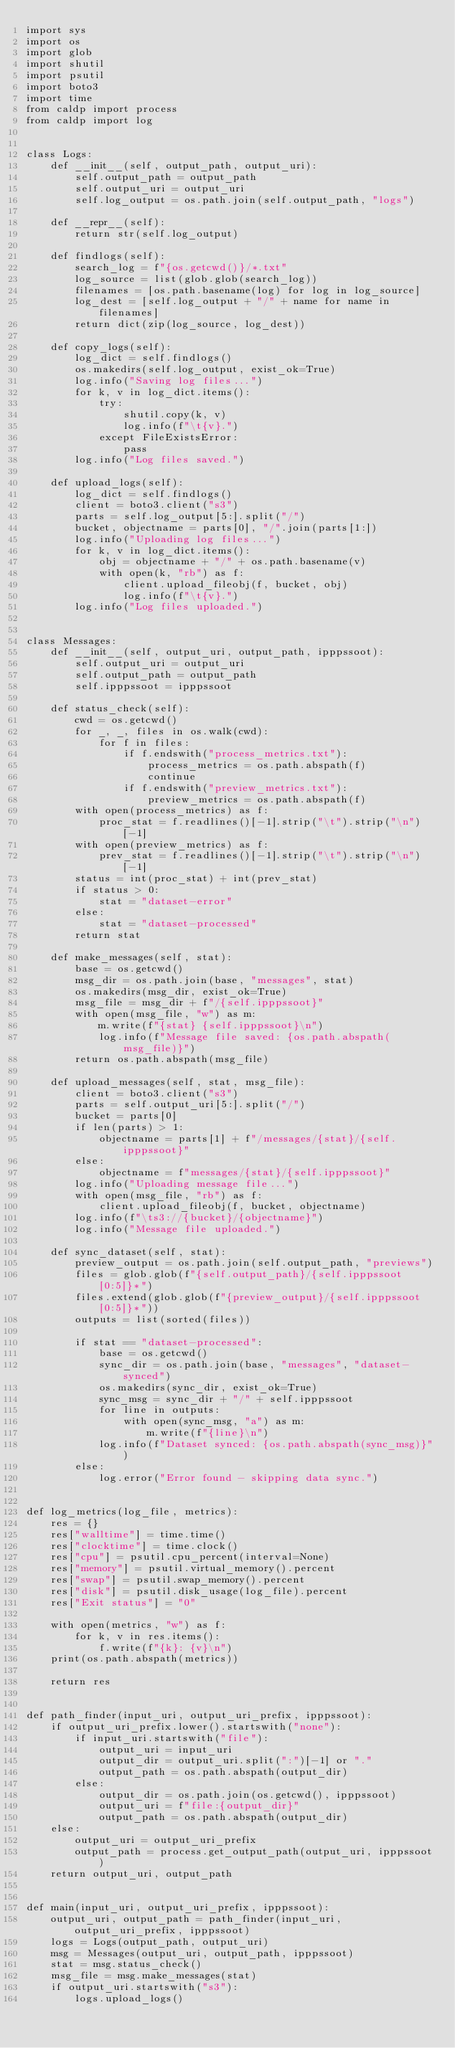<code> <loc_0><loc_0><loc_500><loc_500><_Python_>import sys
import os
import glob
import shutil
import psutil
import boto3
import time
from caldp import process
from caldp import log


class Logs:
    def __init__(self, output_path, output_uri):
        self.output_path = output_path
        self.output_uri = output_uri
        self.log_output = os.path.join(self.output_path, "logs")

    def __repr__(self):
        return str(self.log_output)

    def findlogs(self):
        search_log = f"{os.getcwd()}/*.txt"
        log_source = list(glob.glob(search_log))
        filenames = [os.path.basename(log) for log in log_source]
        log_dest = [self.log_output + "/" + name for name in filenames]
        return dict(zip(log_source, log_dest))

    def copy_logs(self):
        log_dict = self.findlogs()
        os.makedirs(self.log_output, exist_ok=True)
        log.info("Saving log files...")
        for k, v in log_dict.items():
            try:
                shutil.copy(k, v)
                log.info(f"\t{v}.")
            except FileExistsError:
                pass
        log.info("Log files saved.")

    def upload_logs(self):
        log_dict = self.findlogs()
        client = boto3.client("s3")
        parts = self.log_output[5:].split("/")
        bucket, objectname = parts[0], "/".join(parts[1:])
        log.info("Uploading log files...")
        for k, v in log_dict.items():
            obj = objectname + "/" + os.path.basename(v)
            with open(k, "rb") as f:
                client.upload_fileobj(f, bucket, obj)
                log.info(f"\t{v}.")
        log.info("Log files uploaded.")


class Messages:
    def __init__(self, output_uri, output_path, ipppssoot):
        self.output_uri = output_uri
        self.output_path = output_path
        self.ipppssoot = ipppssoot

    def status_check(self):
        cwd = os.getcwd()
        for _, _, files in os.walk(cwd):
            for f in files:
                if f.endswith("process_metrics.txt"):
                    process_metrics = os.path.abspath(f)
                    continue
                if f.endswith("preview_metrics.txt"):
                    preview_metrics = os.path.abspath(f)
        with open(process_metrics) as f:
            proc_stat = f.readlines()[-1].strip("\t").strip("\n")[-1]
        with open(preview_metrics) as f:
            prev_stat = f.readlines()[-1].strip("\t").strip("\n")[-1]
        status = int(proc_stat) + int(prev_stat)
        if status > 0:
            stat = "dataset-error"
        else:
            stat = "dataset-processed"
        return stat

    def make_messages(self, stat):
        base = os.getcwd()
        msg_dir = os.path.join(base, "messages", stat)
        os.makedirs(msg_dir, exist_ok=True)
        msg_file = msg_dir + f"/{self.ipppssoot}"
        with open(msg_file, "w") as m:
            m.write(f"{stat} {self.ipppssoot}\n")
            log.info(f"Message file saved: {os.path.abspath(msg_file)}")
        return os.path.abspath(msg_file)

    def upload_messages(self, stat, msg_file):
        client = boto3.client("s3")
        parts = self.output_uri[5:].split("/")
        bucket = parts[0]
        if len(parts) > 1:
            objectname = parts[1] + f"/messages/{stat}/{self.ipppssoot}"
        else:
            objectname = f"messages/{stat}/{self.ipppssoot}"
        log.info("Uploading message file...")
        with open(msg_file, "rb") as f:
            client.upload_fileobj(f, bucket, objectname)
        log.info(f"\ts3://{bucket}/{objectname}")
        log.info("Message file uploaded.")

    def sync_dataset(self, stat):
        preview_output = os.path.join(self.output_path, "previews")
        files = glob.glob(f"{self.output_path}/{self.ipppssoot[0:5]}*")
        files.extend(glob.glob(f"{preview_output}/{self.ipppssoot[0:5]}*"))
        outputs = list(sorted(files))

        if stat == "dataset-processed":
            base = os.getcwd()
            sync_dir = os.path.join(base, "messages", "dataset-synced")
            os.makedirs(sync_dir, exist_ok=True)
            sync_msg = sync_dir + "/" + self.ipppssoot
            for line in outputs:
                with open(sync_msg, "a") as m:
                    m.write(f"{line}\n")
            log.info(f"Dataset synced: {os.path.abspath(sync_msg)}")
        else:
            log.error("Error found - skipping data sync.")


def log_metrics(log_file, metrics):
    res = {}
    res["walltime"] = time.time()
    res["clocktime"] = time.clock()
    res["cpu"] = psutil.cpu_percent(interval=None)
    res["memory"] = psutil.virtual_memory().percent
    res["swap"] = psutil.swap_memory().percent
    res["disk"] = psutil.disk_usage(log_file).percent
    res["Exit status"] = "0"

    with open(metrics, "w") as f:
        for k, v in res.items():
            f.write(f"{k}: {v}\n")
    print(os.path.abspath(metrics))

    return res


def path_finder(input_uri, output_uri_prefix, ipppssoot):
    if output_uri_prefix.lower().startswith("none"):
        if input_uri.startswith("file"):
            output_uri = input_uri
            output_dir = output_uri.split(":")[-1] or "."
            output_path = os.path.abspath(output_dir)
        else:
            output_dir = os.path.join(os.getcwd(), ipppssoot)
            output_uri = f"file:{output_dir}"
            output_path = os.path.abspath(output_dir)
    else:
        output_uri = output_uri_prefix
        output_path = process.get_output_path(output_uri, ipppssoot)
    return output_uri, output_path


def main(input_uri, output_uri_prefix, ipppssoot):
    output_uri, output_path = path_finder(input_uri, output_uri_prefix, ipppssoot)
    logs = Logs(output_path, output_uri)
    msg = Messages(output_uri, output_path, ipppssoot)
    stat = msg.status_check()
    msg_file = msg.make_messages(stat)
    if output_uri.startswith("s3"):
        logs.upload_logs()</code> 